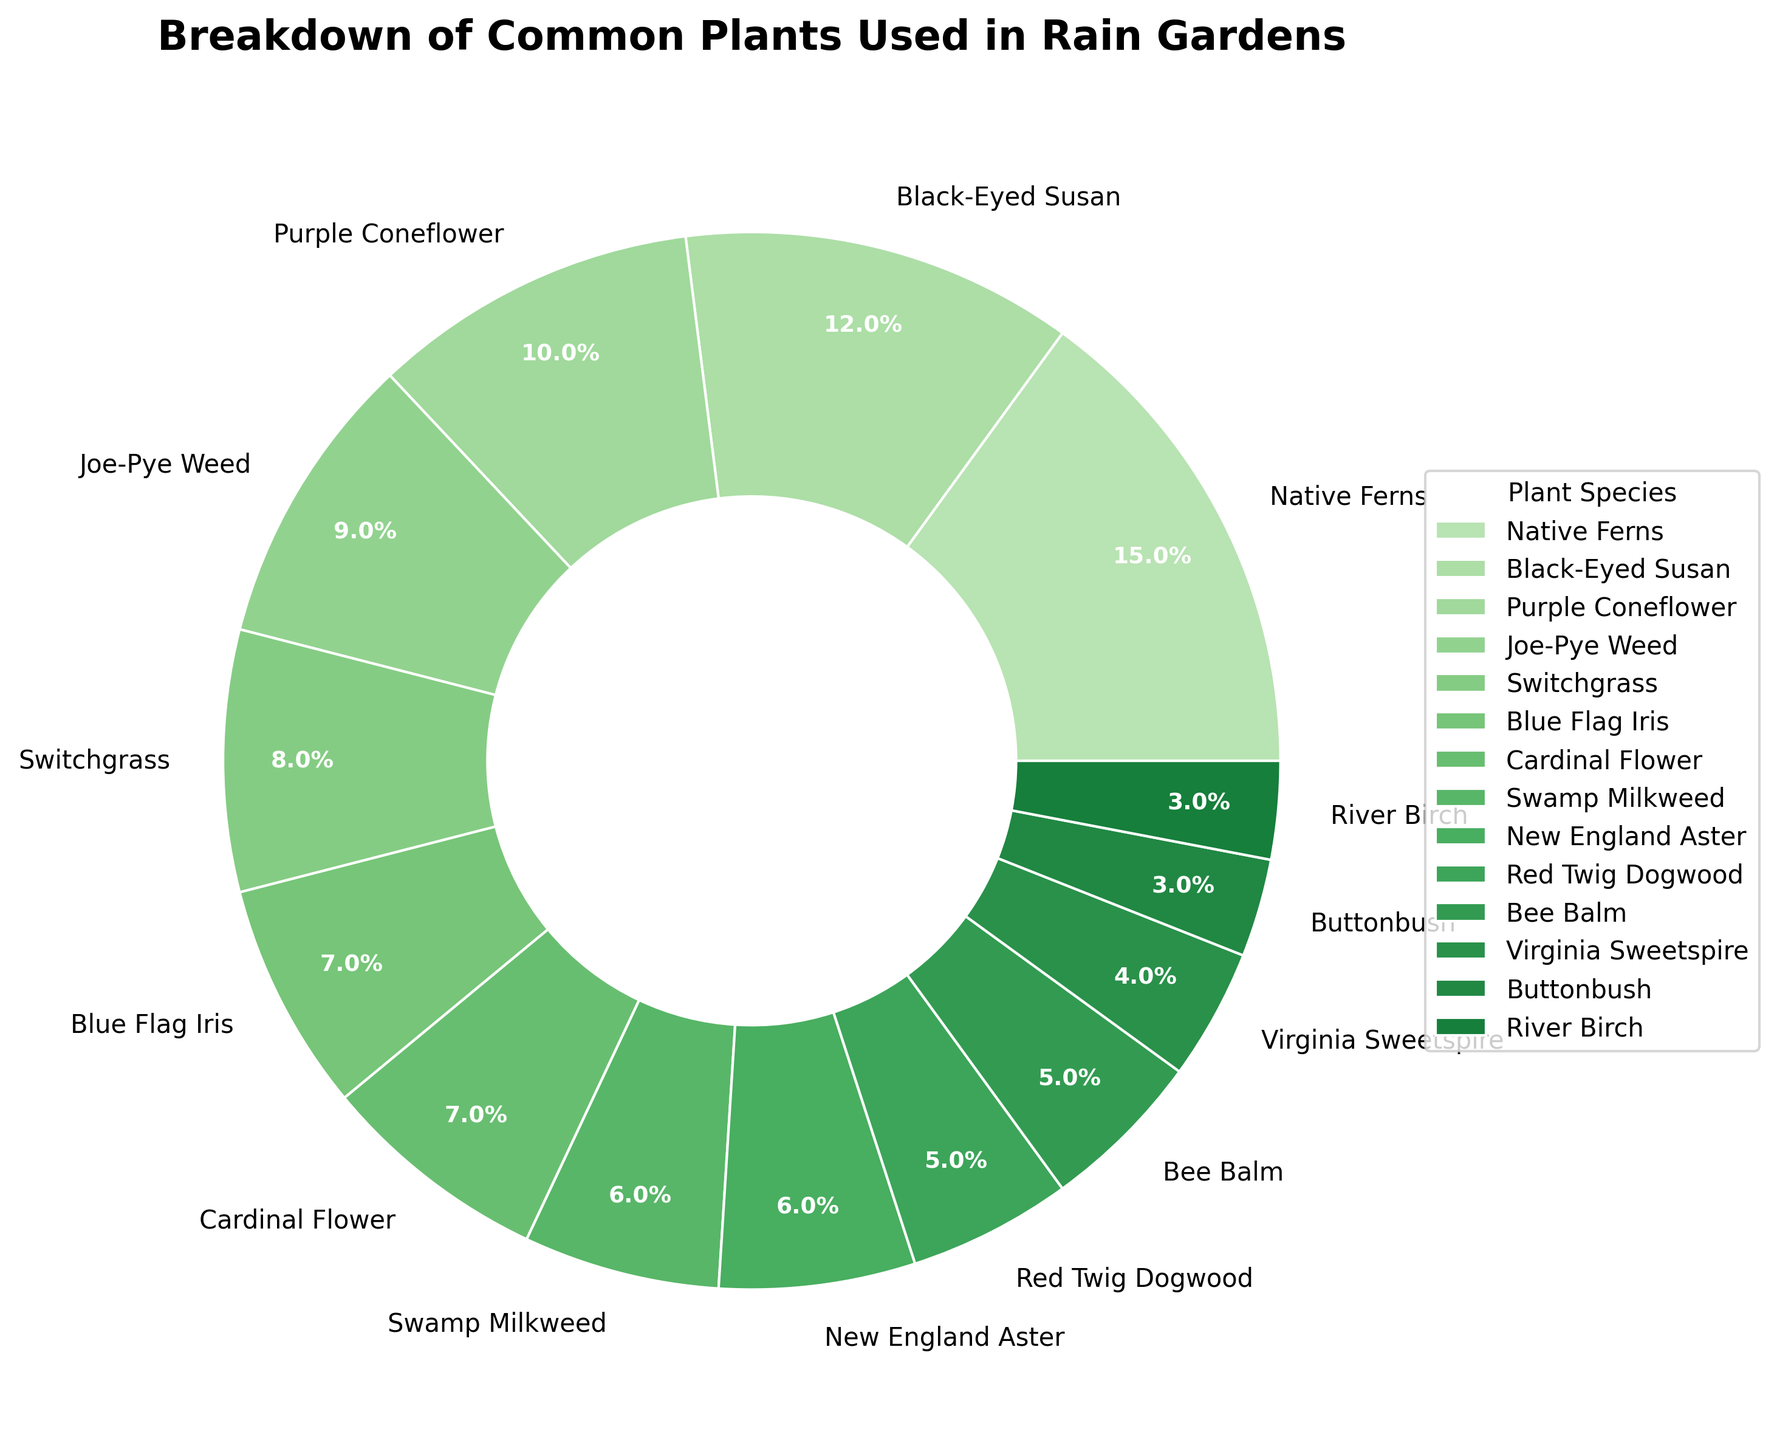What plant species occupies the largest portion in the rain gardens? From the pie chart, the section with the largest percentage is labeled as "Native Ferns," which occupies 15% of the rain gardens.
Answer: Native Ferns What is the total percentage occupied by the top three plant species? The top three plant species by percentage are Native Ferns (15%), Black-Eyed Susan (12%), and Purple Coneflower (10%). Summing these gives 15 + 12 + 10 = 37%.
Answer: 37% How does the percentage of Blue Flag Iris compare to Cardinal Flower? From the pie chart, the Blue Flag Iris occupies 7% and the Cardinal Flower also occupies 7%. Since both species occupy the same percentage, the comparison shows they are equal.
Answer: Equal What is the combined percentage of plant species that occupy less than 5% each? The plant species that occupy less than 5% are Virginia Sweetspire (4%), Buttonbush (3%), and River Birch (3%). Summing these gives 4 + 3 + 3 = 10%.
Answer: 10% Which plant species has the smallest portion in the pie chart, and what is its percentage? The smallest portion in the pie chart is shared by Buttonbush and River Birch, both occupying 3%.
Answer: Buttonbush and River Birch, 3% What is the combined percentage of Swamp Milkweed and New England Aster? Swamp Milkweed occupies 6%, and New England Aster also occupies 6%. Adding these together gives 6 + 6 = 12%.
Answer: 12% Is the percentage of Switchgrass greater than or less than Joe-Pye Weed? Switchgrass occupies 8%, while Joe-Pye Weed occupies 9%. Since 8% is less than 9%, Switchgrass has a lower percentage than Joe-Pye Weed.
Answer: Less What plant species between Bee Balm and Red Twig Dogwood has a higher percentage, and by how much? Bee Balm occupies 5%, and Red Twig Dogwood also occupies 5%. Since both occupy the same percentage, there is no difference.
Answer: Neither, same percentage What is the combined percentage for all plant species with a percentage of 7%? Plant species with a percentage of 7% are Blue Flag Iris (7%) and Cardinal Flower (7%). Their combined percentage is 7 + 7 = 14%.
Answer: 14% What is the total percentage of all plants excluding Native Ferns and Black-Eyed Susan? The total percentage of all plants is 100%. Subtracting the percentages occupied by Native Ferns (15%) and Black-Eyed Susan (12%) gives 100 - 15 - 12 = 73%.
Answer: 73% 